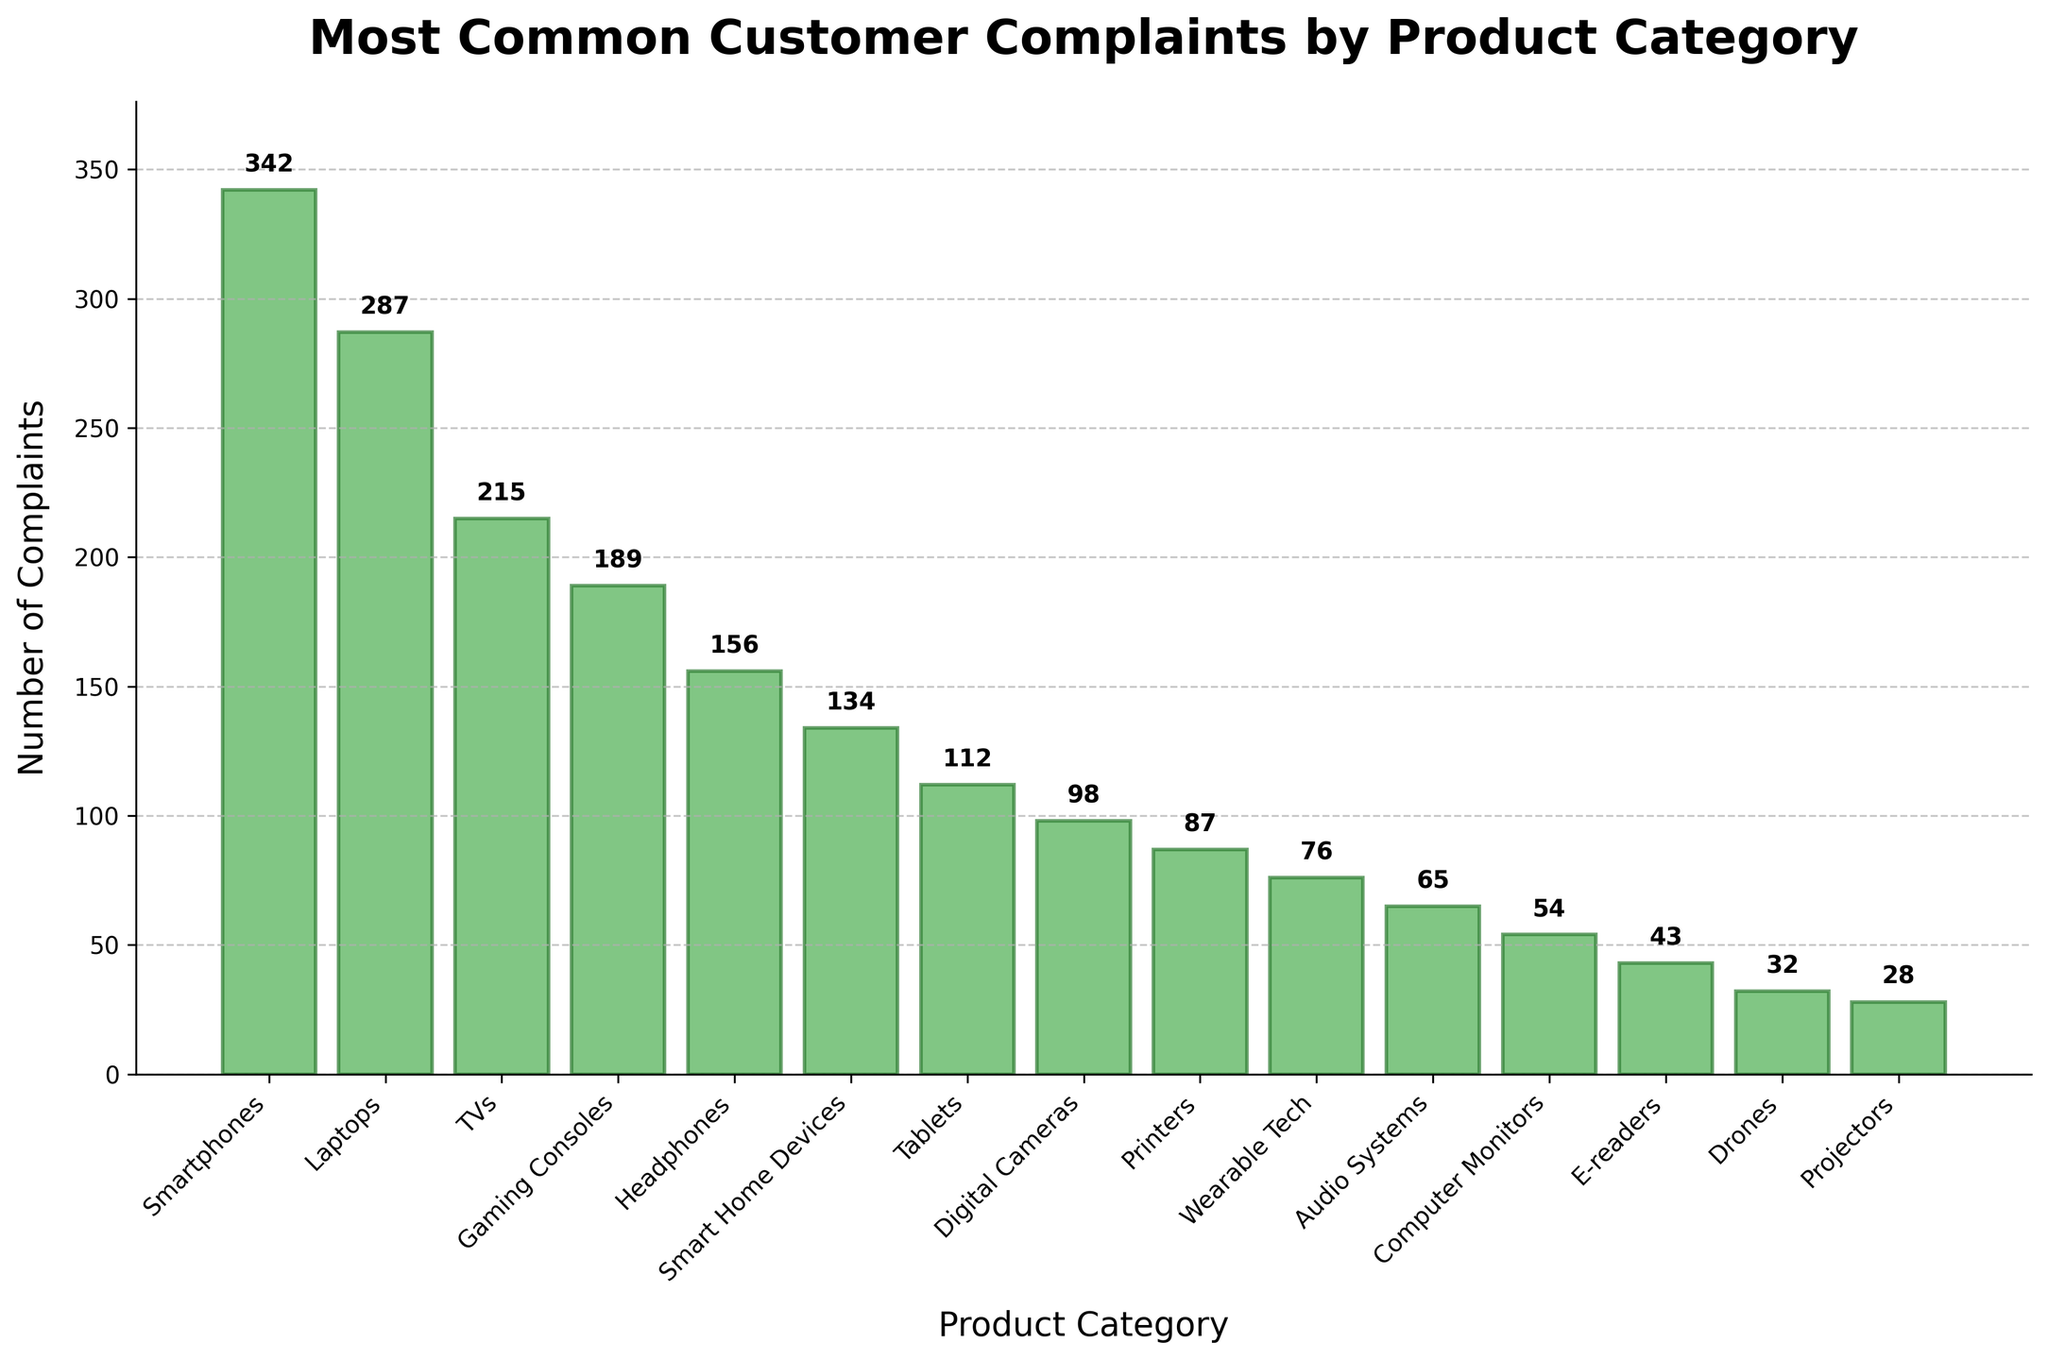Which product category received the highest number of complaints? The bar representing "Smartphones" is the tallest among all the categories, indicating it has the highest number of complaints.
Answer: Smartphones How many complaints were recorded for the least complained-about product category? The shortest bar on the chart represents "Projectors," indicating it has the fewest complaints. The value at the top of this bar is 28.
Answer: 28 What is the total number of complaints for "Smartphones," "Laptops," and "TVs" combined? Add the number of complaints for each category: 342 (Smartphones) + 287 (Laptops) + 215 (TVs) = 844.
Answer: 844 Which product category has fewer complaints, "Tablets" or "Digital Cameras"? By comparing the heights of the bars for "Tablets" and "Digital Cameras," we can see that the bar for "Tablets" is taller (112) than that of "Digital Cameras" (98).
Answer: Digital Cameras What is the average number of complaints across all product categories? Sum all the complaint values: 342 + 287 + 215 + 189 + 156 + 134 + 112 + 98 + 87 + 76 + 65 + 54 + 43 + 32 + 28 = 1918. There are 15 categories, so the average is 1918 / 15 ≈ 127.87.
Answer: 127.87 Which product categories received more than 200 complaints? By looking at the bars taller than 200 units, the categories are "Smartphones" (342), "Laptops" (287), and "TVs" (215).
Answer: Smartphones, Laptops, TVs How many more complaints did "Gaming Consoles" receive compared to "Tablets"? Subtract the smaller number of complaints (Tablets: 112) from the larger number (Gaming Consoles: 189): 189 - 112 = 77.
Answer: 77 Did "Headphones" receive more complaints than "Smart Home Devices"? Compare the heights of the bars for "Headphones" (156) and "Smart Home Devices" (134). Since 156 > 134, "Headphones" received more complaints.
Answer: Yes What is the combined number of complaints for all categories starting with "S"? Sum the complaints for "Smartphones" (342), "Smart Home Devices" (134), and "Speakers" (however, there is no "Speakers" category in the provided data). Thus, only two relevant categories: 342 + 134 = 476.
Answer: 476 On average, how many more complaints were received for "Laptops" than "Printers"? First, find the difference in complaints: 287 (Laptops) - 87 (Printers) = 200. The average more complaints is simply this difference: 200 / 1 = 200.
Answer: 200 